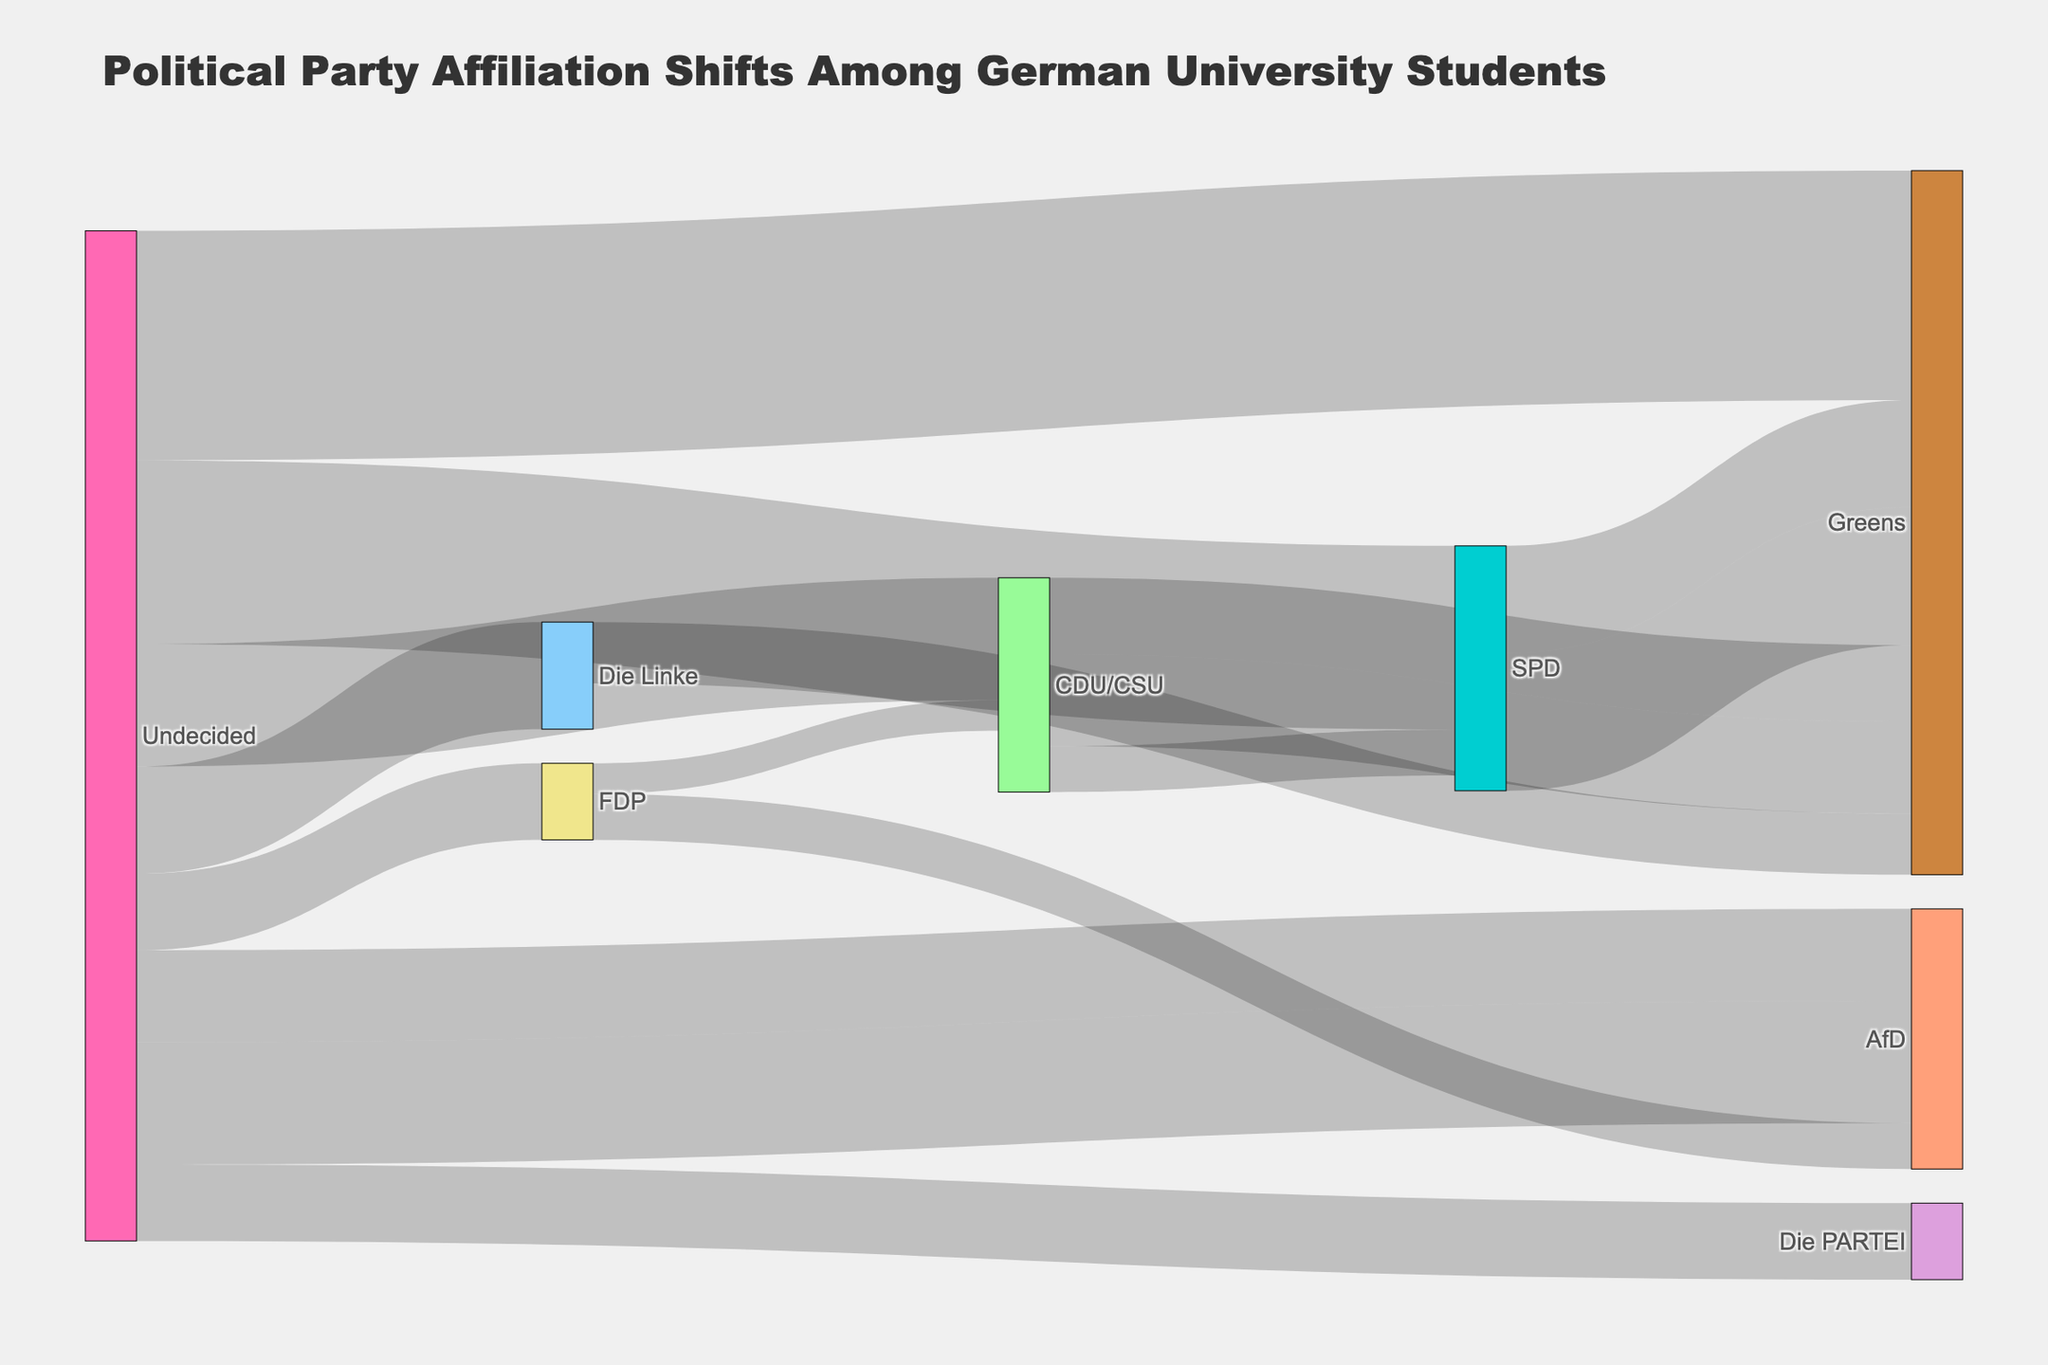What is the title of the Sankey diagram? The title can be found at the top of the diagram displaying the main subject of the visualization.
Answer: Political Party Affiliation Shifts Among German University Students What political party affiliation had the highest number of undecided students shifting towards it in 2010? Look for the "Undecided" source node in 2010, trace flows leading to different parties, and check the values. The highest value will indicate the party with the most shifts.
Answer: Greens How many students shifted from SPD to Greens in 2015 and 2020 combined? Find the flows from SPD to Greens in both 2015 and 2020 and add their values together: 7 in 2015 and 9 in 2020.
Answer: 16 Which political party gained more students from "Undecided" in 2020, AfD or Die PARTEI? Compare the flow values from "Undecided" to AfD and Die PARTEI in 2020.
Answer: AfD What is the total number of undecided students who shifted to any political party in 2010? Sum the flow values from "Undecided" to all political parties in 2010: 8 (CDU/CSU) + 12 (SPD) + 15 (Greens) + 5 (FDP) + 7 (Die Linke).
Answer: 47 Did any flow from FDP to CDU/CSU occur earlier than 2015? Check the years in which the flow from FDP to CDU/CSU appears. Since it starts in 2015, no flow occurred prior.
Answer: No Between which years did undecided students start shifting to AfD? Identify when the flow from "Undecided" to AfD first appears in the data provided.
Answer: 2015 How many students switched from Die Linke to the Greens in 2020? Locate the flow from Die Linke to the Greens in 2020 and note its value.
Answer: 4 Which political party saw an increased inflow from undecided students from 2015 to 2020? Compare the inflows to parties from "Undecided" between 2015 and 2020 and identify if any party received more students in 2020 compared to 2015.
Answer: AfD Is the number of students moving from CDU/CSU to Greens increasing, decreasing, or stable between 2015 and 2020? Compare the flow values from CDU/CSU to Greens in 2015 (5) and 2020 (6).
Answer: Increasing 